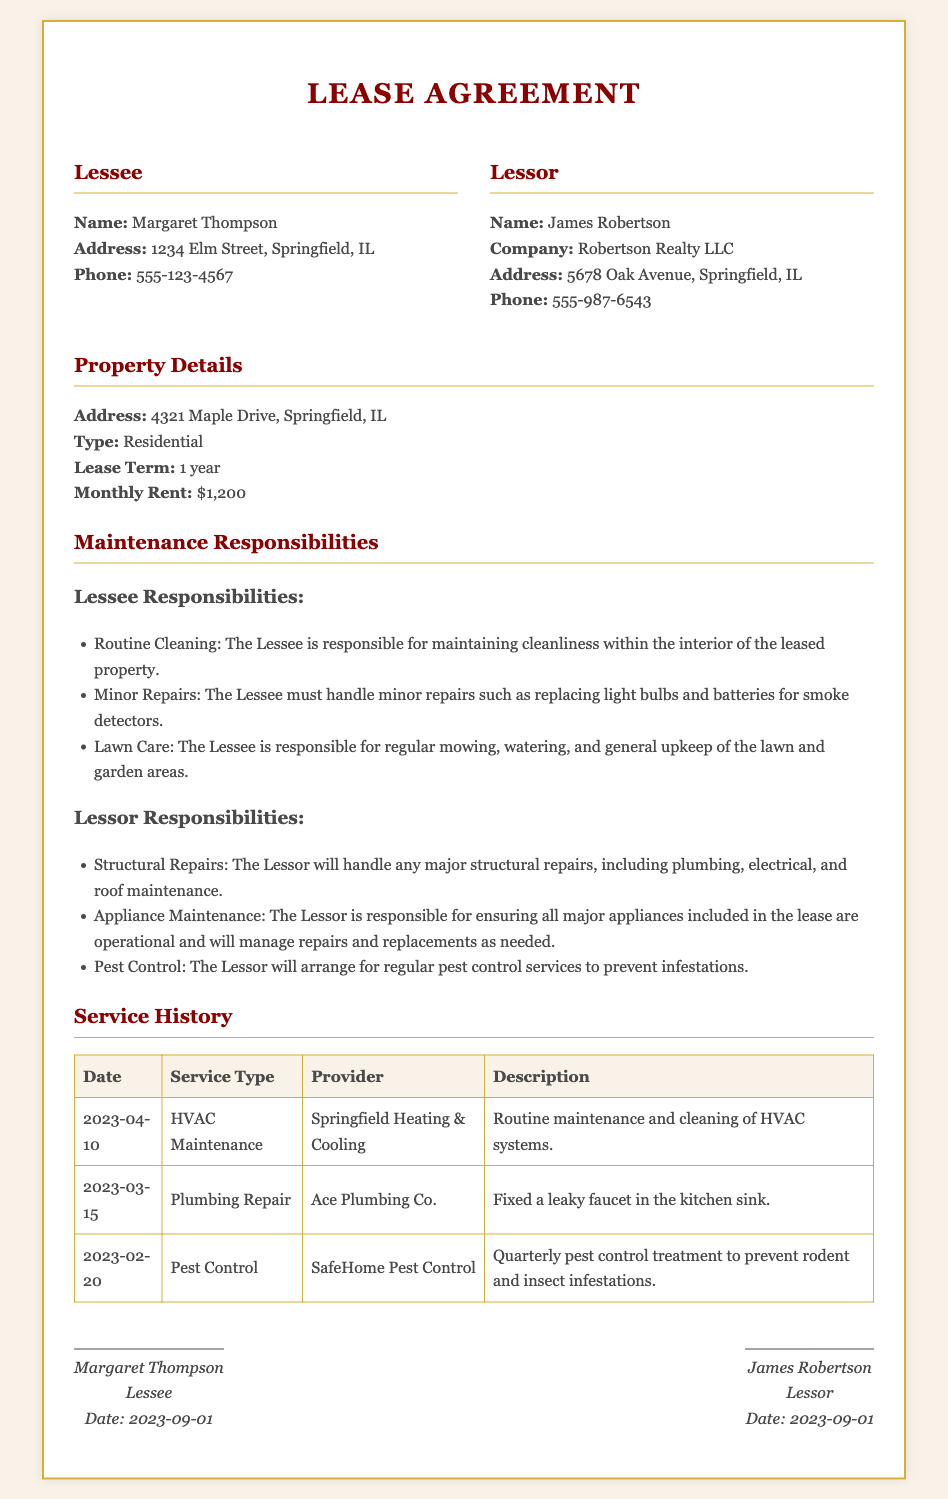what is the name of the lessee? The lessee's name is indicated in the document's party information section, which lists Margaret Thompson.
Answer: Margaret Thompson what is the monthly rent? The monthly rent is specified under property details in the lease agreement.
Answer: $1,200 who is responsible for pest control? The maintenance responsibilities section defines who handles pest control, which is the lessor's duty.
Answer: Lessor when was the HVAC maintenance performed? The service history table provides a date for the HVAC maintenance service, which occurred on April 10, 2023.
Answer: 2023-04-10 what type of property is being leased? The property type is listed in the property details section of the lease agreement.
Answer: Residential what is included in the lessee's responsibilities? The lessee's responsibilities section outlines what duties are required of the lessee, such as routine cleaning.
Answer: Routine Cleaning who performed the plumbing repair? The service history table lists Ace Plumbing Co. as the provider for plumbing repair services.
Answer: Ace Plumbing Co how long is the lease term? The lease term is mentioned under property details, specifying the duration of the lease agreement.
Answer: 1 year what is the last service date recorded in the history? The service history table reveals the most recent service date recorded, which is the HVAC maintenance on April 10, 2023.
Answer: 2023-04-10 